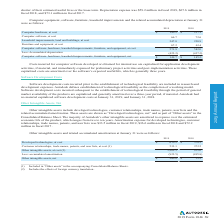According to Autodesk's financial document, What are allowances for uncollectible trade receivables based on? Based on the financial document, the answer is historical loss patterns, the number of days that billings are past due, and an evaluation of the potential risk of loss associated with problem accounts.. Also, What does Autodesk consider the monetary rewards given to partners as? Based on the financial document, the answer is either contra accounts receivable or accounts payable. Also, What was the amount of trade accounts receivable in 2018? Based on the financial document, the answer is $469.2. Also, can you calculate: What are the total deductions for accounts receivables in 2019? Based on the calculation: 526.6-474.3, the result is 52.3 (in millions). The key data points involved are: 474.3, 526.6. Also, can you calculate: What is the difference in net accounts receivable from 2018 to 2019? Based on the calculation: 474.3-438.2, the result is 36.1 (in millions). The key data points involved are: 438.2, 474.3. Also, can you calculate: What is the average trade accounts receivable from 2018 to 2019? To answer this question, I need to perform calculations using the financial data. The calculation is: (526.6+469.2)/2 , which equals 497.9 (in millions). The key data points involved are: 469.2, 526.6. 